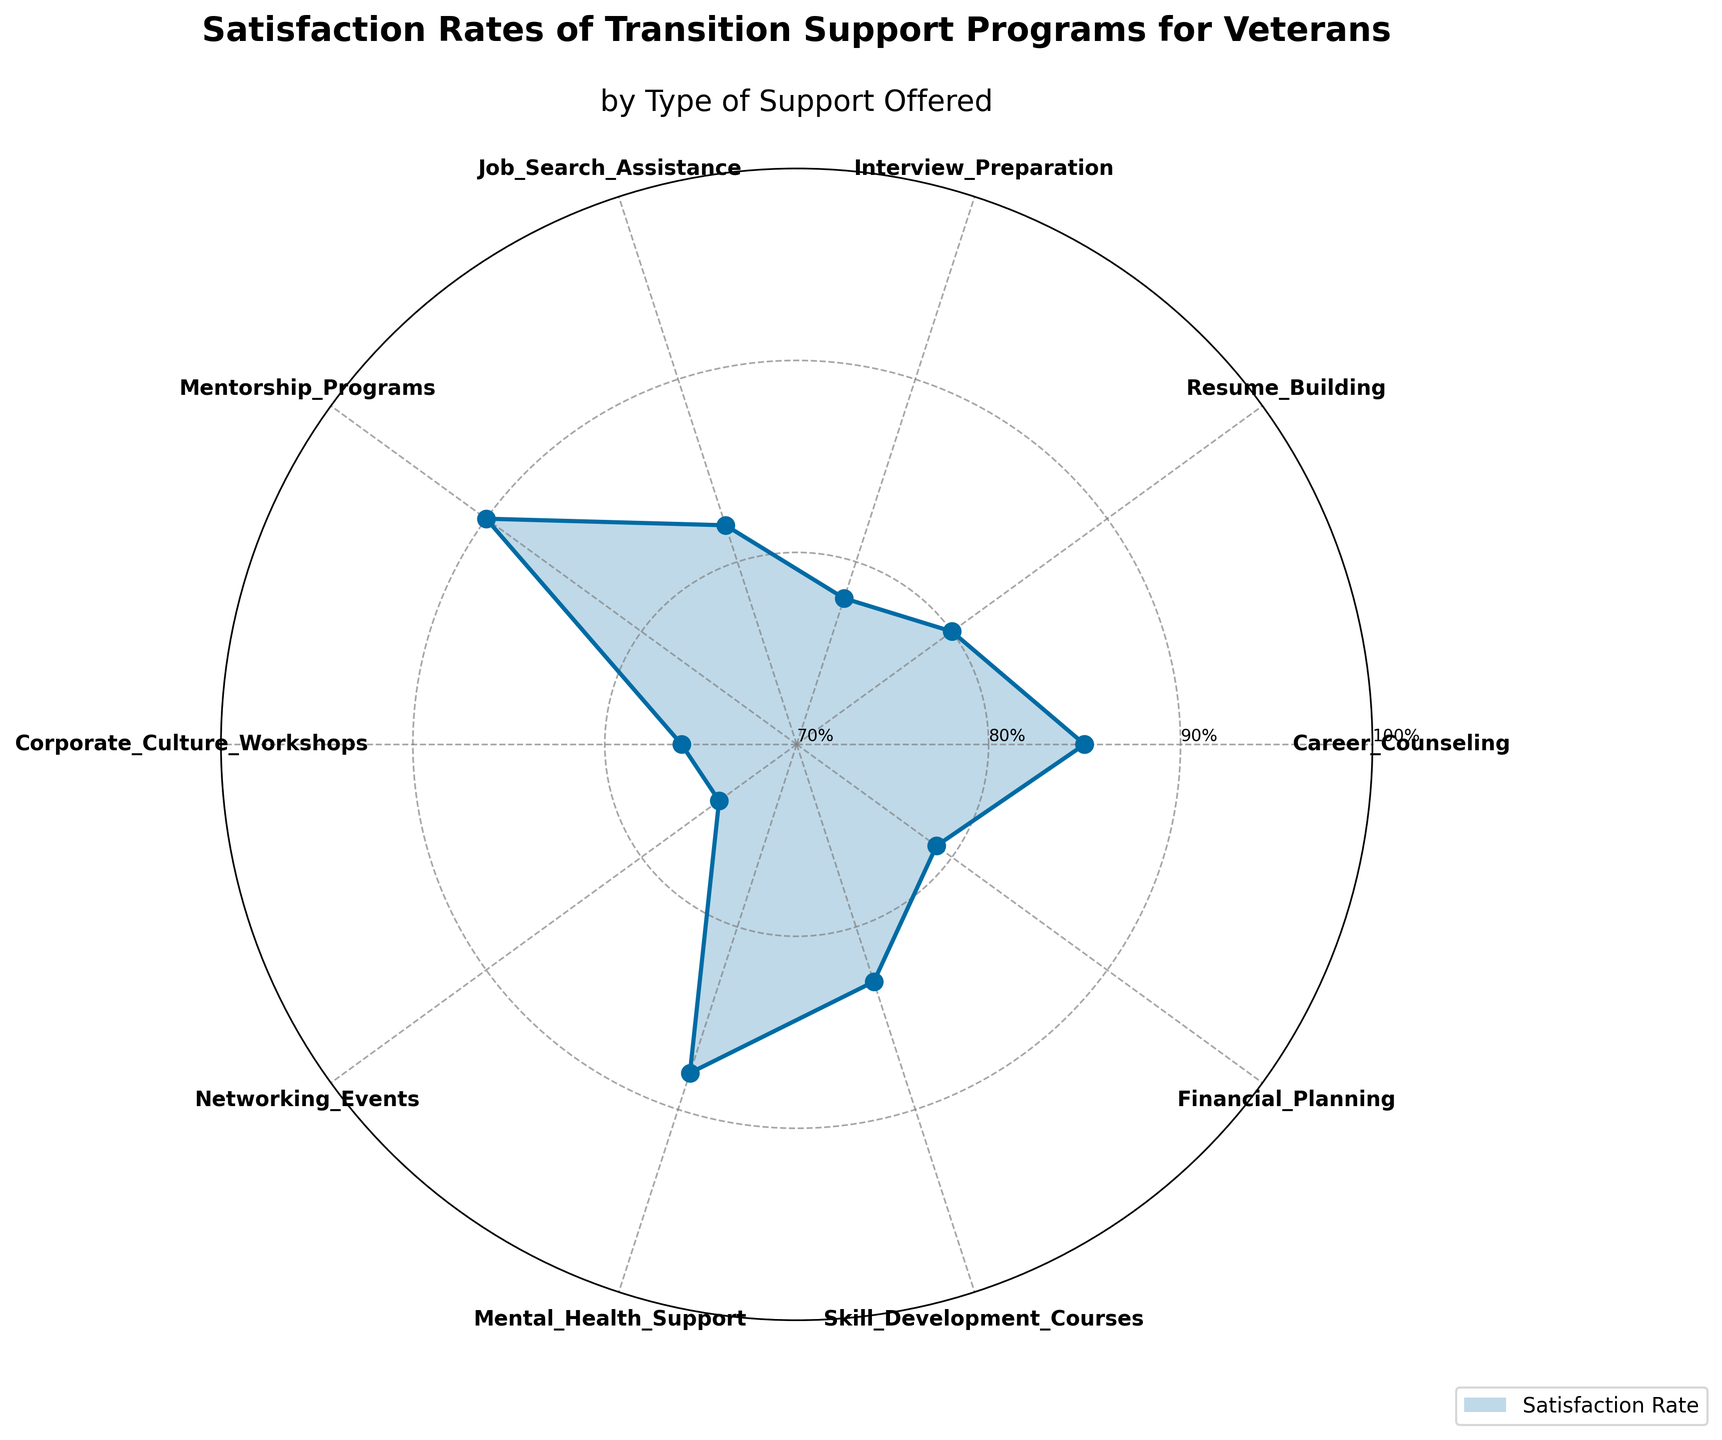What's the title of the chart? The title is usually placed at the top of the chart and is easily visible. In this case, the title is written in bold and larger font compared to other text elements.
Answer: Satisfaction Rates of Transition Support Programs for Veterans How many types of support programs are listed in the chart? By counting the number of unique segments or labels around the chart, you can determine the number of support programs.
Answer: 10 Which support program has the highest satisfaction rate? The highest point at the outermost radial line or circle will represent the program with the maximum satisfaction rate.
Answer: Mentorship Programs What is the satisfaction rate for Financial Planning support? Find the segment labeled 'Financial Planning' and check the length of the corresponding radial line to determine the satisfaction rate.
Answer: 79% How does the satisfaction rate for Career Counseling compare to Mental Health Support? By comparing the lengths of the radial lines for both Career Counseling and Mental Health Support, one can determine which is longer and thus which has a higher satisfaction rate.
Answer: Mental Health Support is 3% higher What's the average satisfaction rate of all support programs? To find the average, you need to sum all the satisfaction rates and divide by the number of support types. The sum is 816 (85+80+78+82+90+76+75+88+83+79), and there are 10 support types, so the average is 816/10 = 81.6.
Answer: 81.6% Which support programs have a satisfaction rate below 80%? Identify the segments with radial lines that are shorter than the 80% marker on the chart.
Answer: Interview Preparation, Corporate Culture Workshops, Networking Events What's the difference in satisfaction rates between Resume Building and Interview Preparation? Subtract the satisfaction rate of Interview Preparation from that of Resume Building (80 - 78).
Answer: 2% Rank the top three support programs based on satisfaction rates. Order the satisfaction rates in descending order and identify the top three segments.
Answer: Mentorship Programs, Mental Health Support, Career Counseling By how much does Skill Development Courses satisfaction rate exceed Corporate Culture Workshops? Subtract the satisfaction rate of Corporate Culture Workshops from that of Skill Development Courses (83 - 76).
Answer: 7% 